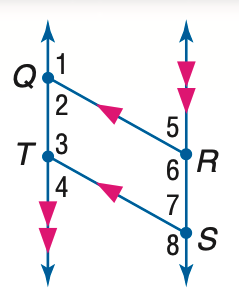Answer the mathemtical geometry problem and directly provide the correct option letter.
Question: In the figure, Q R \parallel T S, Q T \parallel R S, and m \angle 1 = 131. Find the measure of \angle 8.
Choices: A: 101 B: 111 C: 121 D: 131 D 